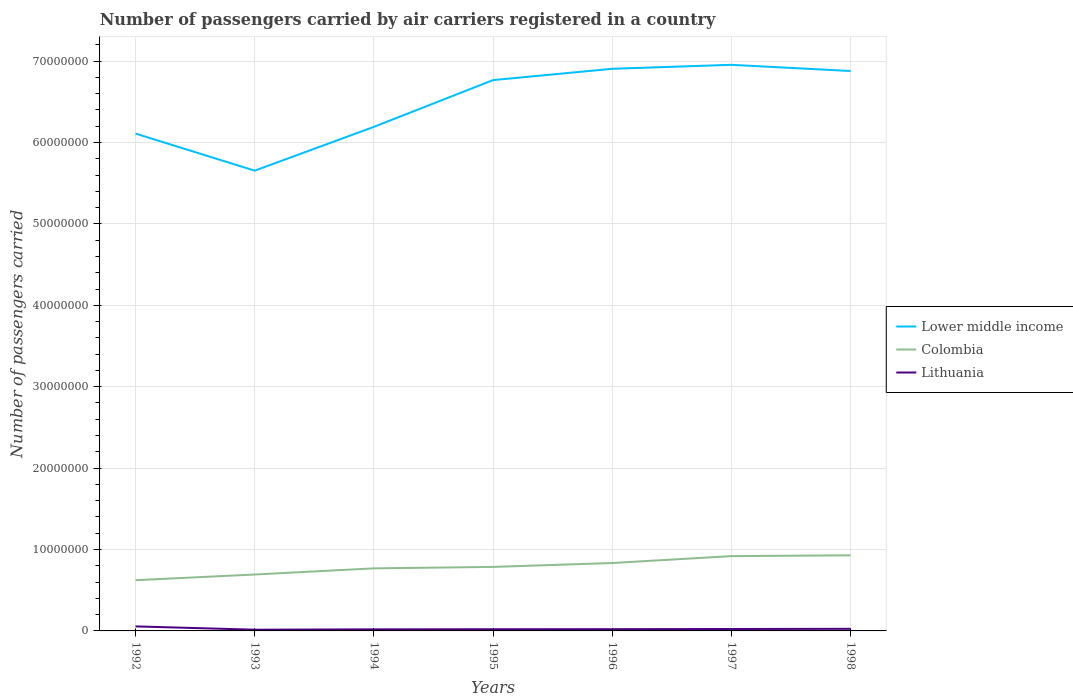How many different coloured lines are there?
Provide a succinct answer. 3. Does the line corresponding to Colombia intersect with the line corresponding to Lithuania?
Offer a very short reply. No. Across all years, what is the maximum number of passengers carried by air carriers in Lower middle income?
Provide a short and direct response. 5.65e+07. In which year was the number of passengers carried by air carriers in Lower middle income maximum?
Provide a short and direct response. 1993. What is the total number of passengers carried by air carriers in Lower middle income in the graph?
Make the answer very short. -1.88e+06. What is the difference between the highest and the second highest number of passengers carried by air carriers in Lower middle income?
Provide a short and direct response. 1.30e+07. What is the difference between the highest and the lowest number of passengers carried by air carriers in Lithuania?
Provide a short and direct response. 1. Is the number of passengers carried by air carriers in Lithuania strictly greater than the number of passengers carried by air carriers in Lower middle income over the years?
Your answer should be very brief. Yes. How many years are there in the graph?
Ensure brevity in your answer.  7. What is the difference between two consecutive major ticks on the Y-axis?
Ensure brevity in your answer.  1.00e+07. Are the values on the major ticks of Y-axis written in scientific E-notation?
Make the answer very short. No. What is the title of the graph?
Give a very brief answer. Number of passengers carried by air carriers registered in a country. Does "High income" appear as one of the legend labels in the graph?
Keep it short and to the point. No. What is the label or title of the X-axis?
Your answer should be very brief. Years. What is the label or title of the Y-axis?
Offer a terse response. Number of passengers carried. What is the Number of passengers carried of Lower middle income in 1992?
Offer a terse response. 6.11e+07. What is the Number of passengers carried of Colombia in 1992?
Provide a short and direct response. 6.23e+06. What is the Number of passengers carried of Lithuania in 1992?
Keep it short and to the point. 5.57e+05. What is the Number of passengers carried in Lower middle income in 1993?
Offer a very short reply. 5.65e+07. What is the Number of passengers carried of Colombia in 1993?
Offer a terse response. 6.93e+06. What is the Number of passengers carried in Lithuania in 1993?
Make the answer very short. 1.50e+05. What is the Number of passengers carried of Lower middle income in 1994?
Keep it short and to the point. 6.19e+07. What is the Number of passengers carried in Colombia in 1994?
Provide a succinct answer. 7.69e+06. What is the Number of passengers carried in Lithuania in 1994?
Offer a very short reply. 1.94e+05. What is the Number of passengers carried of Lower middle income in 1995?
Offer a terse response. 6.77e+07. What is the Number of passengers carried of Colombia in 1995?
Offer a very short reply. 7.86e+06. What is the Number of passengers carried of Lithuania in 1995?
Your response must be concise. 2.10e+05. What is the Number of passengers carried of Lower middle income in 1996?
Ensure brevity in your answer.  6.91e+07. What is the Number of passengers carried in Colombia in 1996?
Offer a terse response. 8.34e+06. What is the Number of passengers carried of Lithuania in 1996?
Ensure brevity in your answer.  2.14e+05. What is the Number of passengers carried of Lower middle income in 1997?
Keep it short and to the point. 6.95e+07. What is the Number of passengers carried of Colombia in 1997?
Ensure brevity in your answer.  9.19e+06. What is the Number of passengers carried of Lithuania in 1997?
Give a very brief answer. 2.37e+05. What is the Number of passengers carried of Lower middle income in 1998?
Give a very brief answer. 6.88e+07. What is the Number of passengers carried in Colombia in 1998?
Offer a terse response. 9.29e+06. What is the Number of passengers carried of Lithuania in 1998?
Keep it short and to the point. 2.59e+05. Across all years, what is the maximum Number of passengers carried in Lower middle income?
Provide a succinct answer. 6.95e+07. Across all years, what is the maximum Number of passengers carried of Colombia?
Your response must be concise. 9.29e+06. Across all years, what is the maximum Number of passengers carried of Lithuania?
Provide a short and direct response. 5.57e+05. Across all years, what is the minimum Number of passengers carried of Lower middle income?
Offer a very short reply. 5.65e+07. Across all years, what is the minimum Number of passengers carried of Colombia?
Ensure brevity in your answer.  6.23e+06. Across all years, what is the minimum Number of passengers carried in Lithuania?
Offer a very short reply. 1.50e+05. What is the total Number of passengers carried in Lower middle income in the graph?
Provide a succinct answer. 4.55e+08. What is the total Number of passengers carried of Colombia in the graph?
Your answer should be compact. 5.55e+07. What is the total Number of passengers carried in Lithuania in the graph?
Your response must be concise. 1.82e+06. What is the difference between the Number of passengers carried of Lower middle income in 1992 and that in 1993?
Provide a short and direct response. 4.56e+06. What is the difference between the Number of passengers carried in Colombia in 1992 and that in 1993?
Provide a short and direct response. -6.98e+05. What is the difference between the Number of passengers carried in Lithuania in 1992 and that in 1993?
Give a very brief answer. 4.08e+05. What is the difference between the Number of passengers carried of Lower middle income in 1992 and that in 1994?
Ensure brevity in your answer.  -8.24e+05. What is the difference between the Number of passengers carried in Colombia in 1992 and that in 1994?
Provide a short and direct response. -1.45e+06. What is the difference between the Number of passengers carried of Lithuania in 1992 and that in 1994?
Your answer should be compact. 3.63e+05. What is the difference between the Number of passengers carried of Lower middle income in 1992 and that in 1995?
Your response must be concise. -6.57e+06. What is the difference between the Number of passengers carried of Colombia in 1992 and that in 1995?
Your response must be concise. -1.63e+06. What is the difference between the Number of passengers carried of Lithuania in 1992 and that in 1995?
Make the answer very short. 3.47e+05. What is the difference between the Number of passengers carried in Lower middle income in 1992 and that in 1996?
Your answer should be compact. -7.96e+06. What is the difference between the Number of passengers carried in Colombia in 1992 and that in 1996?
Your answer should be very brief. -2.11e+06. What is the difference between the Number of passengers carried of Lithuania in 1992 and that in 1996?
Your answer should be very brief. 3.43e+05. What is the difference between the Number of passengers carried in Lower middle income in 1992 and that in 1997?
Ensure brevity in your answer.  -8.45e+06. What is the difference between the Number of passengers carried of Colombia in 1992 and that in 1997?
Your answer should be very brief. -2.96e+06. What is the difference between the Number of passengers carried in Lithuania in 1992 and that in 1997?
Give a very brief answer. 3.20e+05. What is the difference between the Number of passengers carried in Lower middle income in 1992 and that in 1998?
Offer a very short reply. -7.69e+06. What is the difference between the Number of passengers carried in Colombia in 1992 and that in 1998?
Provide a short and direct response. -3.06e+06. What is the difference between the Number of passengers carried in Lithuania in 1992 and that in 1998?
Offer a terse response. 2.98e+05. What is the difference between the Number of passengers carried of Lower middle income in 1993 and that in 1994?
Provide a succinct answer. -5.38e+06. What is the difference between the Number of passengers carried of Colombia in 1993 and that in 1994?
Give a very brief answer. -7.56e+05. What is the difference between the Number of passengers carried in Lithuania in 1993 and that in 1994?
Provide a succinct answer. -4.48e+04. What is the difference between the Number of passengers carried of Lower middle income in 1993 and that in 1995?
Provide a succinct answer. -1.11e+07. What is the difference between the Number of passengers carried in Colombia in 1993 and that in 1995?
Provide a short and direct response. -9.33e+05. What is the difference between the Number of passengers carried of Lithuania in 1993 and that in 1995?
Your answer should be compact. -6.02e+04. What is the difference between the Number of passengers carried of Lower middle income in 1993 and that in 1996?
Offer a terse response. -1.25e+07. What is the difference between the Number of passengers carried in Colombia in 1993 and that in 1996?
Offer a very short reply. -1.41e+06. What is the difference between the Number of passengers carried in Lithuania in 1993 and that in 1996?
Make the answer very short. -6.43e+04. What is the difference between the Number of passengers carried of Lower middle income in 1993 and that in 1997?
Provide a succinct answer. -1.30e+07. What is the difference between the Number of passengers carried of Colombia in 1993 and that in 1997?
Your answer should be compact. -2.26e+06. What is the difference between the Number of passengers carried of Lithuania in 1993 and that in 1997?
Your answer should be compact. -8.71e+04. What is the difference between the Number of passengers carried of Lower middle income in 1993 and that in 1998?
Your answer should be compact. -1.22e+07. What is the difference between the Number of passengers carried in Colombia in 1993 and that in 1998?
Give a very brief answer. -2.36e+06. What is the difference between the Number of passengers carried in Lithuania in 1993 and that in 1998?
Ensure brevity in your answer.  -1.09e+05. What is the difference between the Number of passengers carried of Lower middle income in 1994 and that in 1995?
Give a very brief answer. -5.74e+06. What is the difference between the Number of passengers carried of Colombia in 1994 and that in 1995?
Your response must be concise. -1.77e+05. What is the difference between the Number of passengers carried of Lithuania in 1994 and that in 1995?
Your answer should be very brief. -1.54e+04. What is the difference between the Number of passengers carried in Lower middle income in 1994 and that in 1996?
Provide a succinct answer. -7.13e+06. What is the difference between the Number of passengers carried in Colombia in 1994 and that in 1996?
Give a very brief answer. -6.56e+05. What is the difference between the Number of passengers carried in Lithuania in 1994 and that in 1996?
Provide a short and direct response. -1.95e+04. What is the difference between the Number of passengers carried in Lower middle income in 1994 and that in 1997?
Provide a short and direct response. -7.62e+06. What is the difference between the Number of passengers carried of Colombia in 1994 and that in 1997?
Make the answer very short. -1.50e+06. What is the difference between the Number of passengers carried in Lithuania in 1994 and that in 1997?
Your response must be concise. -4.23e+04. What is the difference between the Number of passengers carried of Lower middle income in 1994 and that in 1998?
Keep it short and to the point. -6.86e+06. What is the difference between the Number of passengers carried in Colombia in 1994 and that in 1998?
Provide a succinct answer. -1.60e+06. What is the difference between the Number of passengers carried in Lithuania in 1994 and that in 1998?
Offer a terse response. -6.44e+04. What is the difference between the Number of passengers carried of Lower middle income in 1995 and that in 1996?
Make the answer very short. -1.39e+06. What is the difference between the Number of passengers carried in Colombia in 1995 and that in 1996?
Offer a very short reply. -4.79e+05. What is the difference between the Number of passengers carried in Lithuania in 1995 and that in 1996?
Your answer should be very brief. -4100. What is the difference between the Number of passengers carried in Lower middle income in 1995 and that in 1997?
Your response must be concise. -1.88e+06. What is the difference between the Number of passengers carried of Colombia in 1995 and that in 1997?
Offer a terse response. -1.33e+06. What is the difference between the Number of passengers carried in Lithuania in 1995 and that in 1997?
Your answer should be compact. -2.69e+04. What is the difference between the Number of passengers carried of Lower middle income in 1995 and that in 1998?
Provide a short and direct response. -1.12e+06. What is the difference between the Number of passengers carried in Colombia in 1995 and that in 1998?
Your answer should be compact. -1.43e+06. What is the difference between the Number of passengers carried in Lithuania in 1995 and that in 1998?
Provide a short and direct response. -4.90e+04. What is the difference between the Number of passengers carried of Lower middle income in 1996 and that in 1997?
Keep it short and to the point. -4.88e+05. What is the difference between the Number of passengers carried in Colombia in 1996 and that in 1997?
Offer a very short reply. -8.47e+05. What is the difference between the Number of passengers carried in Lithuania in 1996 and that in 1997?
Offer a terse response. -2.28e+04. What is the difference between the Number of passengers carried of Lower middle income in 1996 and that in 1998?
Give a very brief answer. 2.72e+05. What is the difference between the Number of passengers carried in Colombia in 1996 and that in 1998?
Give a very brief answer. -9.48e+05. What is the difference between the Number of passengers carried of Lithuania in 1996 and that in 1998?
Your answer should be very brief. -4.49e+04. What is the difference between the Number of passengers carried in Lower middle income in 1997 and that in 1998?
Your answer should be compact. 7.60e+05. What is the difference between the Number of passengers carried of Colombia in 1997 and that in 1998?
Ensure brevity in your answer.  -1.01e+05. What is the difference between the Number of passengers carried of Lithuania in 1997 and that in 1998?
Give a very brief answer. -2.21e+04. What is the difference between the Number of passengers carried in Lower middle income in 1992 and the Number of passengers carried in Colombia in 1993?
Make the answer very short. 5.42e+07. What is the difference between the Number of passengers carried in Lower middle income in 1992 and the Number of passengers carried in Lithuania in 1993?
Give a very brief answer. 6.09e+07. What is the difference between the Number of passengers carried of Colombia in 1992 and the Number of passengers carried of Lithuania in 1993?
Offer a very short reply. 6.08e+06. What is the difference between the Number of passengers carried in Lower middle income in 1992 and the Number of passengers carried in Colombia in 1994?
Offer a terse response. 5.34e+07. What is the difference between the Number of passengers carried of Lower middle income in 1992 and the Number of passengers carried of Lithuania in 1994?
Your answer should be very brief. 6.09e+07. What is the difference between the Number of passengers carried of Colombia in 1992 and the Number of passengers carried of Lithuania in 1994?
Keep it short and to the point. 6.04e+06. What is the difference between the Number of passengers carried of Lower middle income in 1992 and the Number of passengers carried of Colombia in 1995?
Make the answer very short. 5.32e+07. What is the difference between the Number of passengers carried in Lower middle income in 1992 and the Number of passengers carried in Lithuania in 1995?
Make the answer very short. 6.09e+07. What is the difference between the Number of passengers carried of Colombia in 1992 and the Number of passengers carried of Lithuania in 1995?
Offer a terse response. 6.02e+06. What is the difference between the Number of passengers carried of Lower middle income in 1992 and the Number of passengers carried of Colombia in 1996?
Make the answer very short. 5.28e+07. What is the difference between the Number of passengers carried of Lower middle income in 1992 and the Number of passengers carried of Lithuania in 1996?
Keep it short and to the point. 6.09e+07. What is the difference between the Number of passengers carried of Colombia in 1992 and the Number of passengers carried of Lithuania in 1996?
Your response must be concise. 6.02e+06. What is the difference between the Number of passengers carried in Lower middle income in 1992 and the Number of passengers carried in Colombia in 1997?
Your answer should be compact. 5.19e+07. What is the difference between the Number of passengers carried in Lower middle income in 1992 and the Number of passengers carried in Lithuania in 1997?
Provide a succinct answer. 6.09e+07. What is the difference between the Number of passengers carried in Colombia in 1992 and the Number of passengers carried in Lithuania in 1997?
Offer a terse response. 6.00e+06. What is the difference between the Number of passengers carried of Lower middle income in 1992 and the Number of passengers carried of Colombia in 1998?
Make the answer very short. 5.18e+07. What is the difference between the Number of passengers carried in Lower middle income in 1992 and the Number of passengers carried in Lithuania in 1998?
Ensure brevity in your answer.  6.08e+07. What is the difference between the Number of passengers carried of Colombia in 1992 and the Number of passengers carried of Lithuania in 1998?
Make the answer very short. 5.97e+06. What is the difference between the Number of passengers carried in Lower middle income in 1993 and the Number of passengers carried in Colombia in 1994?
Provide a succinct answer. 4.89e+07. What is the difference between the Number of passengers carried of Lower middle income in 1993 and the Number of passengers carried of Lithuania in 1994?
Ensure brevity in your answer.  5.63e+07. What is the difference between the Number of passengers carried of Colombia in 1993 and the Number of passengers carried of Lithuania in 1994?
Give a very brief answer. 6.74e+06. What is the difference between the Number of passengers carried in Lower middle income in 1993 and the Number of passengers carried in Colombia in 1995?
Ensure brevity in your answer.  4.87e+07. What is the difference between the Number of passengers carried of Lower middle income in 1993 and the Number of passengers carried of Lithuania in 1995?
Keep it short and to the point. 5.63e+07. What is the difference between the Number of passengers carried of Colombia in 1993 and the Number of passengers carried of Lithuania in 1995?
Your answer should be compact. 6.72e+06. What is the difference between the Number of passengers carried of Lower middle income in 1993 and the Number of passengers carried of Colombia in 1996?
Your answer should be compact. 4.82e+07. What is the difference between the Number of passengers carried of Lower middle income in 1993 and the Number of passengers carried of Lithuania in 1996?
Ensure brevity in your answer.  5.63e+07. What is the difference between the Number of passengers carried of Colombia in 1993 and the Number of passengers carried of Lithuania in 1996?
Your answer should be very brief. 6.72e+06. What is the difference between the Number of passengers carried of Lower middle income in 1993 and the Number of passengers carried of Colombia in 1997?
Offer a very short reply. 4.74e+07. What is the difference between the Number of passengers carried in Lower middle income in 1993 and the Number of passengers carried in Lithuania in 1997?
Your response must be concise. 5.63e+07. What is the difference between the Number of passengers carried in Colombia in 1993 and the Number of passengers carried in Lithuania in 1997?
Offer a terse response. 6.69e+06. What is the difference between the Number of passengers carried of Lower middle income in 1993 and the Number of passengers carried of Colombia in 1998?
Your answer should be very brief. 4.73e+07. What is the difference between the Number of passengers carried in Lower middle income in 1993 and the Number of passengers carried in Lithuania in 1998?
Your answer should be very brief. 5.63e+07. What is the difference between the Number of passengers carried in Colombia in 1993 and the Number of passengers carried in Lithuania in 1998?
Give a very brief answer. 6.67e+06. What is the difference between the Number of passengers carried of Lower middle income in 1994 and the Number of passengers carried of Colombia in 1995?
Ensure brevity in your answer.  5.41e+07. What is the difference between the Number of passengers carried in Lower middle income in 1994 and the Number of passengers carried in Lithuania in 1995?
Your answer should be compact. 6.17e+07. What is the difference between the Number of passengers carried of Colombia in 1994 and the Number of passengers carried of Lithuania in 1995?
Offer a very short reply. 7.48e+06. What is the difference between the Number of passengers carried of Lower middle income in 1994 and the Number of passengers carried of Colombia in 1996?
Keep it short and to the point. 5.36e+07. What is the difference between the Number of passengers carried in Lower middle income in 1994 and the Number of passengers carried in Lithuania in 1996?
Your response must be concise. 6.17e+07. What is the difference between the Number of passengers carried of Colombia in 1994 and the Number of passengers carried of Lithuania in 1996?
Your answer should be compact. 7.47e+06. What is the difference between the Number of passengers carried of Lower middle income in 1994 and the Number of passengers carried of Colombia in 1997?
Your answer should be compact. 5.27e+07. What is the difference between the Number of passengers carried in Lower middle income in 1994 and the Number of passengers carried in Lithuania in 1997?
Give a very brief answer. 6.17e+07. What is the difference between the Number of passengers carried in Colombia in 1994 and the Number of passengers carried in Lithuania in 1997?
Offer a terse response. 7.45e+06. What is the difference between the Number of passengers carried in Lower middle income in 1994 and the Number of passengers carried in Colombia in 1998?
Provide a short and direct response. 5.26e+07. What is the difference between the Number of passengers carried of Lower middle income in 1994 and the Number of passengers carried of Lithuania in 1998?
Ensure brevity in your answer.  6.17e+07. What is the difference between the Number of passengers carried of Colombia in 1994 and the Number of passengers carried of Lithuania in 1998?
Your answer should be compact. 7.43e+06. What is the difference between the Number of passengers carried in Lower middle income in 1995 and the Number of passengers carried in Colombia in 1996?
Make the answer very short. 5.93e+07. What is the difference between the Number of passengers carried in Lower middle income in 1995 and the Number of passengers carried in Lithuania in 1996?
Keep it short and to the point. 6.75e+07. What is the difference between the Number of passengers carried of Colombia in 1995 and the Number of passengers carried of Lithuania in 1996?
Make the answer very short. 7.65e+06. What is the difference between the Number of passengers carried in Lower middle income in 1995 and the Number of passengers carried in Colombia in 1997?
Give a very brief answer. 5.85e+07. What is the difference between the Number of passengers carried of Lower middle income in 1995 and the Number of passengers carried of Lithuania in 1997?
Offer a very short reply. 6.74e+07. What is the difference between the Number of passengers carried of Colombia in 1995 and the Number of passengers carried of Lithuania in 1997?
Your answer should be compact. 7.63e+06. What is the difference between the Number of passengers carried in Lower middle income in 1995 and the Number of passengers carried in Colombia in 1998?
Your answer should be compact. 5.84e+07. What is the difference between the Number of passengers carried in Lower middle income in 1995 and the Number of passengers carried in Lithuania in 1998?
Your response must be concise. 6.74e+07. What is the difference between the Number of passengers carried in Colombia in 1995 and the Number of passengers carried in Lithuania in 1998?
Provide a succinct answer. 7.60e+06. What is the difference between the Number of passengers carried of Lower middle income in 1996 and the Number of passengers carried of Colombia in 1997?
Offer a very short reply. 5.99e+07. What is the difference between the Number of passengers carried of Lower middle income in 1996 and the Number of passengers carried of Lithuania in 1997?
Provide a succinct answer. 6.88e+07. What is the difference between the Number of passengers carried in Colombia in 1996 and the Number of passengers carried in Lithuania in 1997?
Provide a short and direct response. 8.11e+06. What is the difference between the Number of passengers carried in Lower middle income in 1996 and the Number of passengers carried in Colombia in 1998?
Make the answer very short. 5.98e+07. What is the difference between the Number of passengers carried in Lower middle income in 1996 and the Number of passengers carried in Lithuania in 1998?
Provide a short and direct response. 6.88e+07. What is the difference between the Number of passengers carried in Colombia in 1996 and the Number of passengers carried in Lithuania in 1998?
Keep it short and to the point. 8.08e+06. What is the difference between the Number of passengers carried in Lower middle income in 1997 and the Number of passengers carried in Colombia in 1998?
Provide a succinct answer. 6.03e+07. What is the difference between the Number of passengers carried of Lower middle income in 1997 and the Number of passengers carried of Lithuania in 1998?
Make the answer very short. 6.93e+07. What is the difference between the Number of passengers carried of Colombia in 1997 and the Number of passengers carried of Lithuania in 1998?
Your answer should be compact. 8.93e+06. What is the average Number of passengers carried of Lower middle income per year?
Provide a succinct answer. 6.49e+07. What is the average Number of passengers carried in Colombia per year?
Ensure brevity in your answer.  7.93e+06. What is the average Number of passengers carried of Lithuania per year?
Give a very brief answer. 2.60e+05. In the year 1992, what is the difference between the Number of passengers carried of Lower middle income and Number of passengers carried of Colombia?
Make the answer very short. 5.49e+07. In the year 1992, what is the difference between the Number of passengers carried in Lower middle income and Number of passengers carried in Lithuania?
Your response must be concise. 6.05e+07. In the year 1992, what is the difference between the Number of passengers carried in Colombia and Number of passengers carried in Lithuania?
Ensure brevity in your answer.  5.67e+06. In the year 1993, what is the difference between the Number of passengers carried of Lower middle income and Number of passengers carried of Colombia?
Provide a succinct answer. 4.96e+07. In the year 1993, what is the difference between the Number of passengers carried in Lower middle income and Number of passengers carried in Lithuania?
Offer a very short reply. 5.64e+07. In the year 1993, what is the difference between the Number of passengers carried of Colombia and Number of passengers carried of Lithuania?
Provide a short and direct response. 6.78e+06. In the year 1994, what is the difference between the Number of passengers carried of Lower middle income and Number of passengers carried of Colombia?
Your response must be concise. 5.42e+07. In the year 1994, what is the difference between the Number of passengers carried of Lower middle income and Number of passengers carried of Lithuania?
Your answer should be compact. 6.17e+07. In the year 1994, what is the difference between the Number of passengers carried of Colombia and Number of passengers carried of Lithuania?
Your response must be concise. 7.49e+06. In the year 1995, what is the difference between the Number of passengers carried of Lower middle income and Number of passengers carried of Colombia?
Your answer should be very brief. 5.98e+07. In the year 1995, what is the difference between the Number of passengers carried of Lower middle income and Number of passengers carried of Lithuania?
Give a very brief answer. 6.75e+07. In the year 1995, what is the difference between the Number of passengers carried of Colombia and Number of passengers carried of Lithuania?
Provide a succinct answer. 7.65e+06. In the year 1996, what is the difference between the Number of passengers carried of Lower middle income and Number of passengers carried of Colombia?
Make the answer very short. 6.07e+07. In the year 1996, what is the difference between the Number of passengers carried in Lower middle income and Number of passengers carried in Lithuania?
Provide a short and direct response. 6.88e+07. In the year 1996, what is the difference between the Number of passengers carried in Colombia and Number of passengers carried in Lithuania?
Provide a succinct answer. 8.13e+06. In the year 1997, what is the difference between the Number of passengers carried of Lower middle income and Number of passengers carried of Colombia?
Keep it short and to the point. 6.04e+07. In the year 1997, what is the difference between the Number of passengers carried in Lower middle income and Number of passengers carried in Lithuania?
Offer a terse response. 6.93e+07. In the year 1997, what is the difference between the Number of passengers carried of Colombia and Number of passengers carried of Lithuania?
Provide a succinct answer. 8.95e+06. In the year 1998, what is the difference between the Number of passengers carried in Lower middle income and Number of passengers carried in Colombia?
Offer a very short reply. 5.95e+07. In the year 1998, what is the difference between the Number of passengers carried in Lower middle income and Number of passengers carried in Lithuania?
Provide a succinct answer. 6.85e+07. In the year 1998, what is the difference between the Number of passengers carried of Colombia and Number of passengers carried of Lithuania?
Provide a succinct answer. 9.03e+06. What is the ratio of the Number of passengers carried of Lower middle income in 1992 to that in 1993?
Your answer should be compact. 1.08. What is the ratio of the Number of passengers carried in Colombia in 1992 to that in 1993?
Provide a short and direct response. 0.9. What is the ratio of the Number of passengers carried of Lithuania in 1992 to that in 1993?
Your answer should be very brief. 3.72. What is the ratio of the Number of passengers carried of Lower middle income in 1992 to that in 1994?
Your answer should be very brief. 0.99. What is the ratio of the Number of passengers carried of Colombia in 1992 to that in 1994?
Keep it short and to the point. 0.81. What is the ratio of the Number of passengers carried in Lithuania in 1992 to that in 1994?
Make the answer very short. 2.86. What is the ratio of the Number of passengers carried in Lower middle income in 1992 to that in 1995?
Give a very brief answer. 0.9. What is the ratio of the Number of passengers carried in Colombia in 1992 to that in 1995?
Offer a very short reply. 0.79. What is the ratio of the Number of passengers carried in Lithuania in 1992 to that in 1995?
Offer a very short reply. 2.65. What is the ratio of the Number of passengers carried in Lower middle income in 1992 to that in 1996?
Ensure brevity in your answer.  0.88. What is the ratio of the Number of passengers carried of Colombia in 1992 to that in 1996?
Offer a terse response. 0.75. What is the ratio of the Number of passengers carried of Lithuania in 1992 to that in 1996?
Your answer should be compact. 2.6. What is the ratio of the Number of passengers carried of Lower middle income in 1992 to that in 1997?
Ensure brevity in your answer.  0.88. What is the ratio of the Number of passengers carried in Colombia in 1992 to that in 1997?
Your answer should be compact. 0.68. What is the ratio of the Number of passengers carried of Lithuania in 1992 to that in 1997?
Provide a short and direct response. 2.35. What is the ratio of the Number of passengers carried in Lower middle income in 1992 to that in 1998?
Your response must be concise. 0.89. What is the ratio of the Number of passengers carried in Colombia in 1992 to that in 1998?
Your answer should be compact. 0.67. What is the ratio of the Number of passengers carried in Lithuania in 1992 to that in 1998?
Provide a succinct answer. 2.15. What is the ratio of the Number of passengers carried of Lower middle income in 1993 to that in 1994?
Your response must be concise. 0.91. What is the ratio of the Number of passengers carried of Colombia in 1993 to that in 1994?
Provide a short and direct response. 0.9. What is the ratio of the Number of passengers carried of Lithuania in 1993 to that in 1994?
Provide a succinct answer. 0.77. What is the ratio of the Number of passengers carried of Lower middle income in 1993 to that in 1995?
Keep it short and to the point. 0.84. What is the ratio of the Number of passengers carried in Colombia in 1993 to that in 1995?
Give a very brief answer. 0.88. What is the ratio of the Number of passengers carried of Lithuania in 1993 to that in 1995?
Provide a short and direct response. 0.71. What is the ratio of the Number of passengers carried in Lower middle income in 1993 to that in 1996?
Keep it short and to the point. 0.82. What is the ratio of the Number of passengers carried in Colombia in 1993 to that in 1996?
Make the answer very short. 0.83. What is the ratio of the Number of passengers carried in Lithuania in 1993 to that in 1996?
Offer a very short reply. 0.7. What is the ratio of the Number of passengers carried in Lower middle income in 1993 to that in 1997?
Keep it short and to the point. 0.81. What is the ratio of the Number of passengers carried in Colombia in 1993 to that in 1997?
Your answer should be compact. 0.75. What is the ratio of the Number of passengers carried in Lithuania in 1993 to that in 1997?
Give a very brief answer. 0.63. What is the ratio of the Number of passengers carried in Lower middle income in 1993 to that in 1998?
Your answer should be compact. 0.82. What is the ratio of the Number of passengers carried of Colombia in 1993 to that in 1998?
Provide a short and direct response. 0.75. What is the ratio of the Number of passengers carried of Lithuania in 1993 to that in 1998?
Your answer should be compact. 0.58. What is the ratio of the Number of passengers carried in Lower middle income in 1994 to that in 1995?
Give a very brief answer. 0.92. What is the ratio of the Number of passengers carried of Colombia in 1994 to that in 1995?
Provide a short and direct response. 0.98. What is the ratio of the Number of passengers carried in Lithuania in 1994 to that in 1995?
Ensure brevity in your answer.  0.93. What is the ratio of the Number of passengers carried in Lower middle income in 1994 to that in 1996?
Your answer should be compact. 0.9. What is the ratio of the Number of passengers carried in Colombia in 1994 to that in 1996?
Your response must be concise. 0.92. What is the ratio of the Number of passengers carried in Lithuania in 1994 to that in 1996?
Give a very brief answer. 0.91. What is the ratio of the Number of passengers carried in Lower middle income in 1994 to that in 1997?
Ensure brevity in your answer.  0.89. What is the ratio of the Number of passengers carried in Colombia in 1994 to that in 1997?
Provide a succinct answer. 0.84. What is the ratio of the Number of passengers carried in Lithuania in 1994 to that in 1997?
Your response must be concise. 0.82. What is the ratio of the Number of passengers carried of Lower middle income in 1994 to that in 1998?
Give a very brief answer. 0.9. What is the ratio of the Number of passengers carried in Colombia in 1994 to that in 1998?
Offer a terse response. 0.83. What is the ratio of the Number of passengers carried in Lithuania in 1994 to that in 1998?
Your response must be concise. 0.75. What is the ratio of the Number of passengers carried in Lower middle income in 1995 to that in 1996?
Provide a succinct answer. 0.98. What is the ratio of the Number of passengers carried in Colombia in 1995 to that in 1996?
Provide a short and direct response. 0.94. What is the ratio of the Number of passengers carried of Lithuania in 1995 to that in 1996?
Your answer should be compact. 0.98. What is the ratio of the Number of passengers carried in Lower middle income in 1995 to that in 1997?
Keep it short and to the point. 0.97. What is the ratio of the Number of passengers carried in Colombia in 1995 to that in 1997?
Offer a very short reply. 0.86. What is the ratio of the Number of passengers carried in Lithuania in 1995 to that in 1997?
Your answer should be compact. 0.89. What is the ratio of the Number of passengers carried in Lower middle income in 1995 to that in 1998?
Provide a succinct answer. 0.98. What is the ratio of the Number of passengers carried of Colombia in 1995 to that in 1998?
Make the answer very short. 0.85. What is the ratio of the Number of passengers carried in Lithuania in 1995 to that in 1998?
Provide a succinct answer. 0.81. What is the ratio of the Number of passengers carried in Lower middle income in 1996 to that in 1997?
Offer a very short reply. 0.99. What is the ratio of the Number of passengers carried in Colombia in 1996 to that in 1997?
Your answer should be compact. 0.91. What is the ratio of the Number of passengers carried in Lithuania in 1996 to that in 1997?
Provide a short and direct response. 0.9. What is the ratio of the Number of passengers carried of Lower middle income in 1996 to that in 1998?
Ensure brevity in your answer.  1. What is the ratio of the Number of passengers carried in Colombia in 1996 to that in 1998?
Make the answer very short. 0.9. What is the ratio of the Number of passengers carried of Lithuania in 1996 to that in 1998?
Make the answer very short. 0.83. What is the ratio of the Number of passengers carried of Lower middle income in 1997 to that in 1998?
Give a very brief answer. 1.01. What is the ratio of the Number of passengers carried of Colombia in 1997 to that in 1998?
Keep it short and to the point. 0.99. What is the ratio of the Number of passengers carried of Lithuania in 1997 to that in 1998?
Your answer should be very brief. 0.91. What is the difference between the highest and the second highest Number of passengers carried in Lower middle income?
Your response must be concise. 4.88e+05. What is the difference between the highest and the second highest Number of passengers carried in Colombia?
Keep it short and to the point. 1.01e+05. What is the difference between the highest and the second highest Number of passengers carried of Lithuania?
Make the answer very short. 2.98e+05. What is the difference between the highest and the lowest Number of passengers carried in Lower middle income?
Provide a short and direct response. 1.30e+07. What is the difference between the highest and the lowest Number of passengers carried of Colombia?
Your answer should be compact. 3.06e+06. What is the difference between the highest and the lowest Number of passengers carried in Lithuania?
Your answer should be compact. 4.08e+05. 